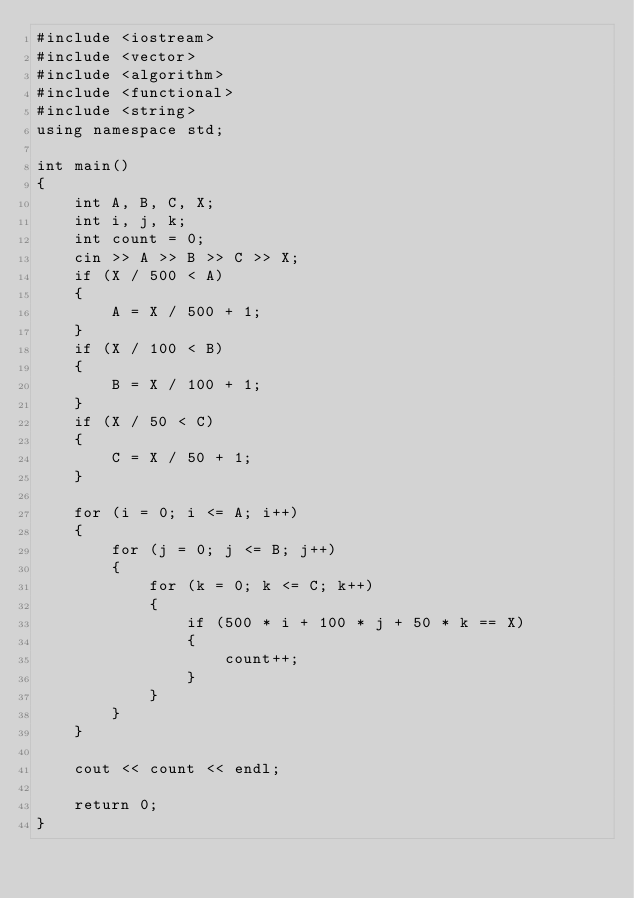<code> <loc_0><loc_0><loc_500><loc_500><_C++_>#include <iostream>
#include <vector>
#include <algorithm>
#include <functional>
#include <string>
using namespace std;

int main()
{
    int A, B, C, X;
    int i, j, k;
    int count = 0;
    cin >> A >> B >> C >> X;
    if (X / 500 < A)
    {
        A = X / 500 + 1;
    }
    if (X / 100 < B)
    {
        B = X / 100 + 1;
    }
    if (X / 50 < C)
    {
        C = X / 50 + 1;
    }

    for (i = 0; i <= A; i++)
    {
        for (j = 0; j <= B; j++)
        {
            for (k = 0; k <= C; k++)
            {
                if (500 * i + 100 * j + 50 * k == X)
                {
                    count++;
                }
            }
        }
    }

    cout << count << endl;

    return 0;
}</code> 